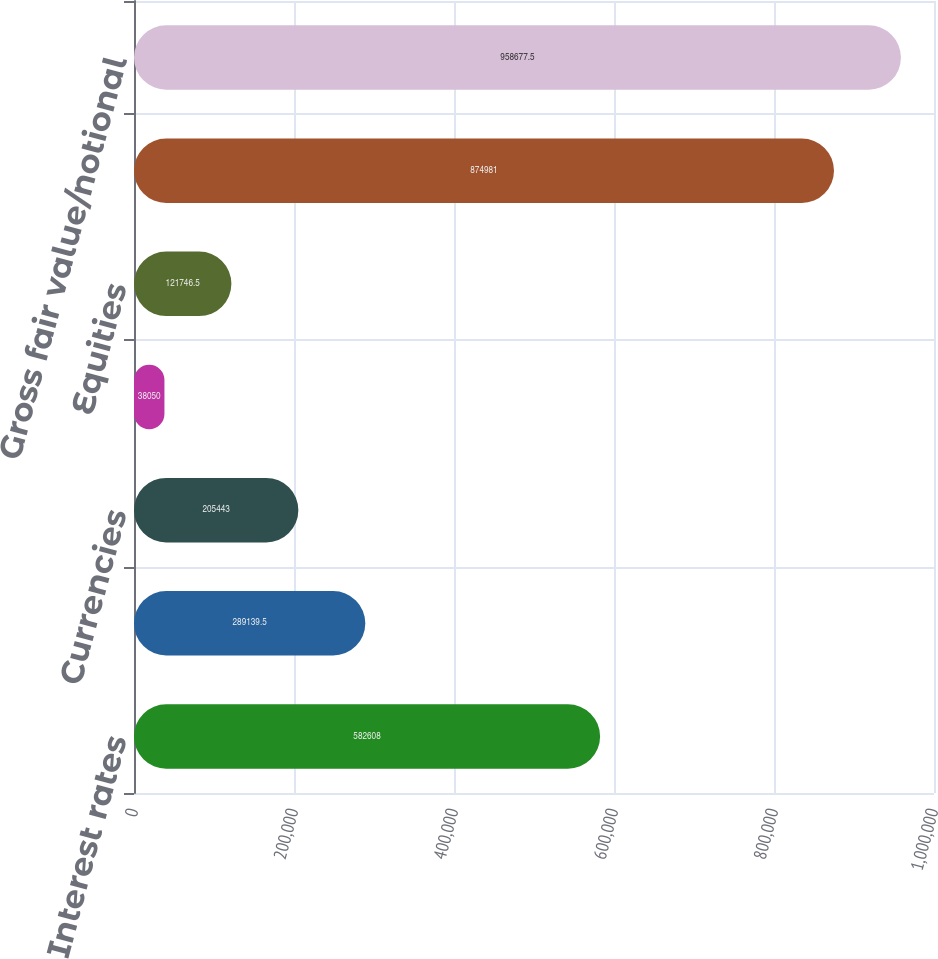Convert chart to OTSL. <chart><loc_0><loc_0><loc_500><loc_500><bar_chart><fcel>Interest rates<fcel>Credit<fcel>Currencies<fcel>Commodities<fcel>Equities<fcel>Subtotal<fcel>Gross fair value/notional<nl><fcel>582608<fcel>289140<fcel>205443<fcel>38050<fcel>121746<fcel>874981<fcel>958678<nl></chart> 